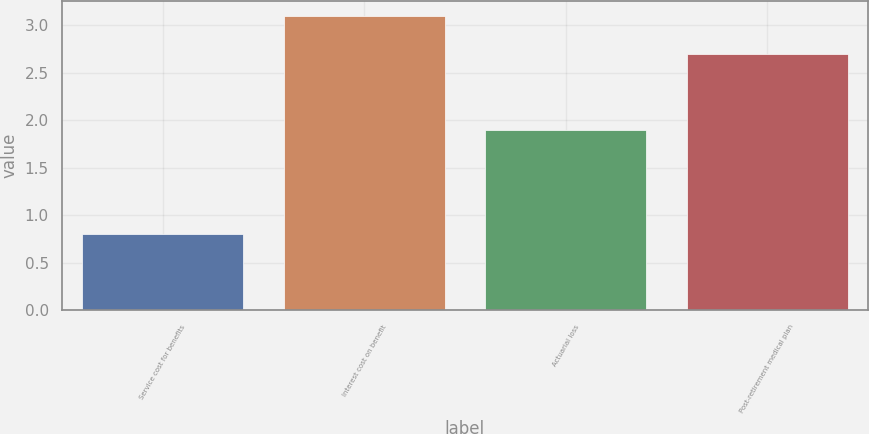<chart> <loc_0><loc_0><loc_500><loc_500><bar_chart><fcel>Service cost for benefits<fcel>Interest cost on benefit<fcel>Actuarial loss<fcel>Post-retirement medical plan<nl><fcel>0.8<fcel>3.1<fcel>1.9<fcel>2.7<nl></chart> 